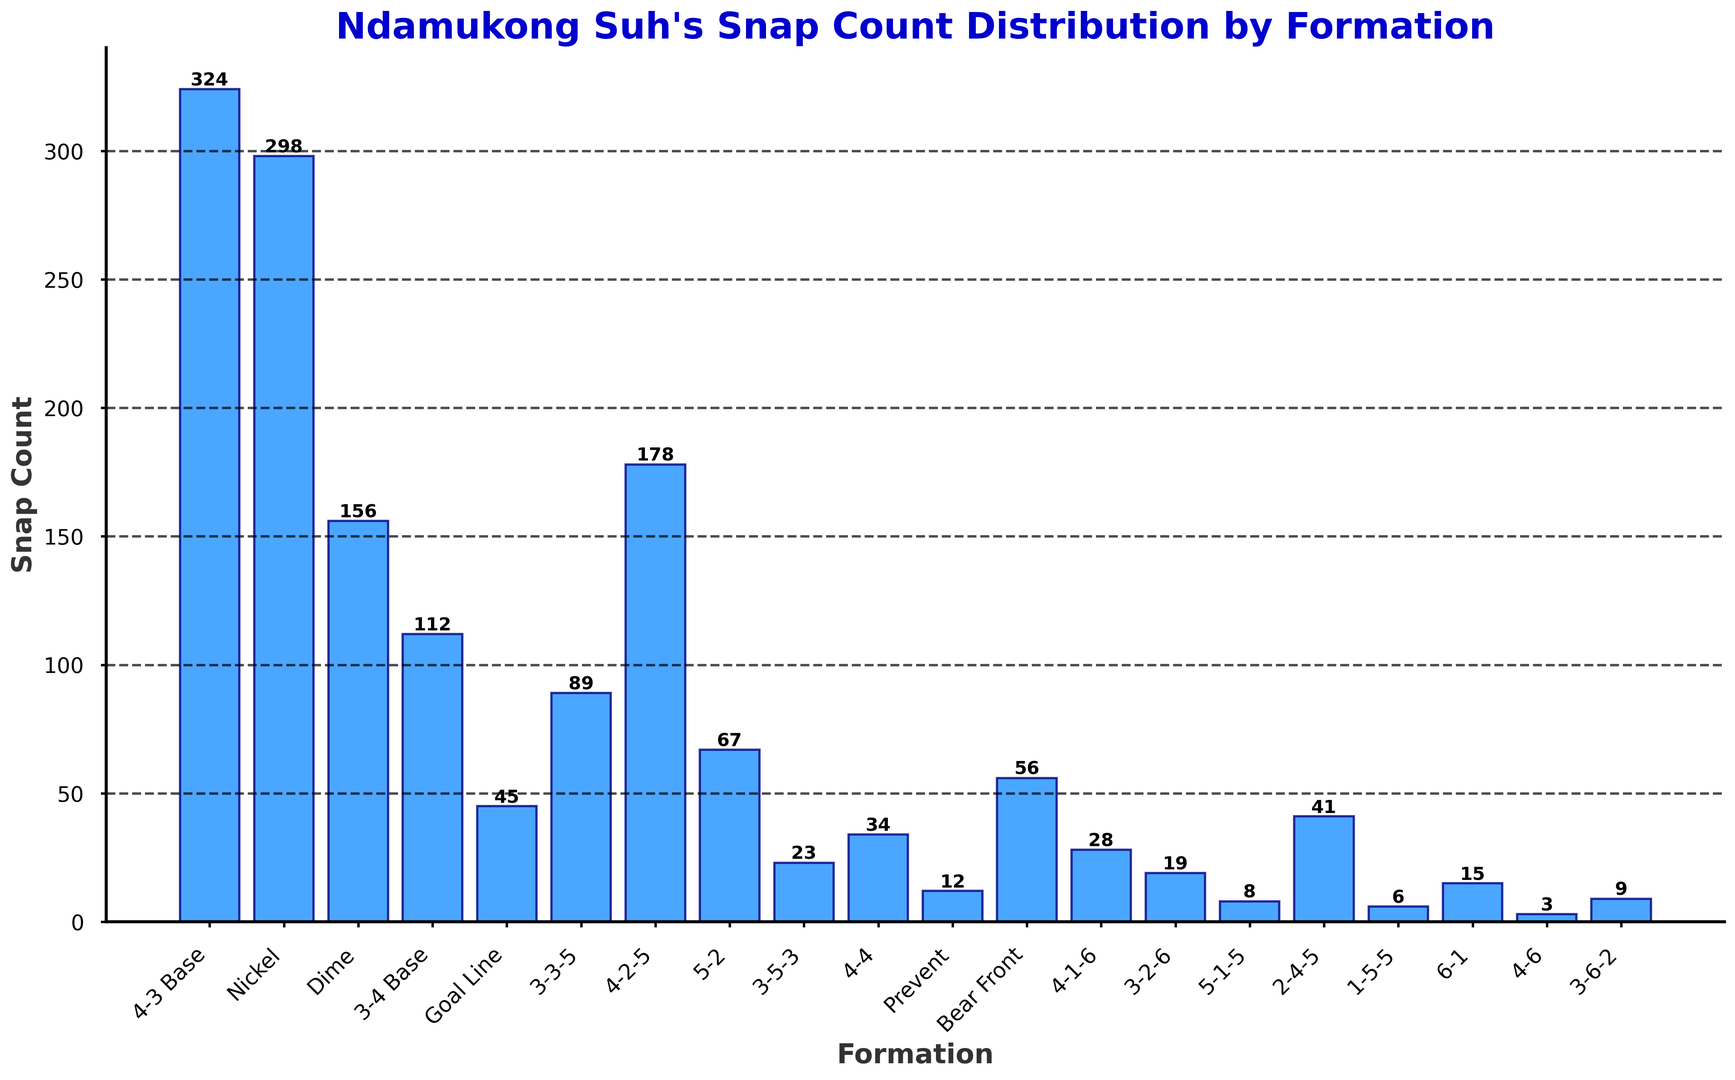What's the most common defensive formation used by Ndamukong Suh? The bar for the "4-3 Base" formation is the tallest among all bars in the histogram, indicating that it has the highest snap count.
Answer: 4-3 Base Which formation has a higher snap count, Nickel or Dime? By comparing the heights of the bars for "Nickel" and "Dime," it is clear that the bar for "Nickel" is taller, indicating a larger snap count.
Answer: Nickel How many formations have a snap count lower than 50? Looking at the heights of the bars, we identify the formations with snap counts lower than 50. These are Goal Line, 3-5-3, Prevent, 4-1-6, 3-2-6, 5-1-5, 1-5-5, and 4-6, totaling 8 formations.
Answer: 8 What's the combined snap count for the "3-4 Base" and the "4-2-5" formations? The snap count for "3-4 Base" is 112, and for "4-2-5" it is 178. Adding them together gives 112 + 178 = 290.
Answer: 290 Is the snap count for the "Goal Line" formation greater than the "3-3-5" formation? By comparing the heights of the bars for "Goal Line" and "3-3-5," it is evident that "Goal Line" has a lower snap count than "3-3-5".
Answer: No Which formation has the lowest snap count, and what is it? The bar for the "4-6" formation is the shortest among all, indicating the lowest snap count of 3.
Answer: 4-6; 3 What is the snap count difference between the "4-3 Base" and the "Nickel" formations? The snap count for "4-3 Base" is 324, and for "Nickel" it is 298. The difference is 324 - 298 = 26.
Answer: 26 Among the formations with snap counts between 50 and 100, which one has the highest snap count? The formations in this range are 3-3-5, Bear Front, and 5-2. Comparing their bars, "3-3-5" has a snap count of 89, "Bear Front" has 56, and "5-2" has 67. The highest is "3-3-5" with 89.
Answer: 3-3-5 